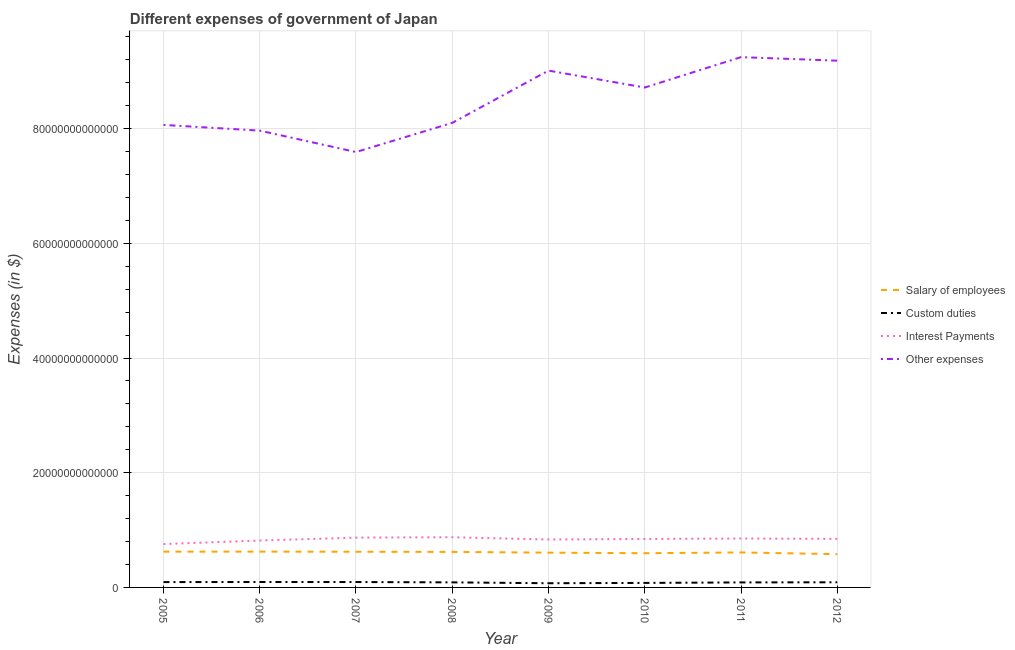Is the number of lines equal to the number of legend labels?
Your answer should be compact. Yes. What is the amount spent on salary of employees in 2009?
Your answer should be very brief. 6.06e+12. Across all years, what is the maximum amount spent on other expenses?
Offer a very short reply. 9.25e+13. Across all years, what is the minimum amount spent on custom duties?
Offer a terse response. 7.32e+11. What is the total amount spent on other expenses in the graph?
Offer a very short reply. 6.79e+14. What is the difference between the amount spent on custom duties in 2007 and that in 2008?
Your answer should be very brief. 5.79e+1. What is the difference between the amount spent on custom duties in 2012 and the amount spent on salary of employees in 2009?
Ensure brevity in your answer.  -5.17e+12. What is the average amount spent on custom duties per year?
Provide a succinct answer. 8.74e+11. In the year 2012, what is the difference between the amount spent on interest payments and amount spent on custom duties?
Ensure brevity in your answer.  7.57e+12. In how many years, is the amount spent on salary of employees greater than 32000000000000 $?
Make the answer very short. 0. What is the ratio of the amount spent on other expenses in 2008 to that in 2011?
Your response must be concise. 0.88. Is the amount spent on custom duties in 2005 less than that in 2006?
Ensure brevity in your answer.  Yes. What is the difference between the highest and the second highest amount spent on salary of employees?
Ensure brevity in your answer.  4.30e+09. What is the difference between the highest and the lowest amount spent on other expenses?
Ensure brevity in your answer.  1.65e+13. Is the sum of the amount spent on other expenses in 2008 and 2010 greater than the maximum amount spent on custom duties across all years?
Keep it short and to the point. Yes. Does the amount spent on salary of employees monotonically increase over the years?
Keep it short and to the point. No. How many lines are there?
Give a very brief answer. 4. What is the difference between two consecutive major ticks on the Y-axis?
Give a very brief answer. 2.00e+13. Are the values on the major ticks of Y-axis written in scientific E-notation?
Provide a succinct answer. No. Does the graph contain grids?
Keep it short and to the point. Yes. Where does the legend appear in the graph?
Offer a terse response. Center right. How many legend labels are there?
Give a very brief answer. 4. How are the legend labels stacked?
Ensure brevity in your answer.  Vertical. What is the title of the graph?
Ensure brevity in your answer.  Different expenses of government of Japan. What is the label or title of the X-axis?
Offer a terse response. Year. What is the label or title of the Y-axis?
Keep it short and to the point. Expenses (in $). What is the Expenses (in $) of Salary of employees in 2005?
Keep it short and to the point. 6.24e+12. What is the Expenses (in $) of Custom duties in 2005?
Your answer should be very brief. 9.30e+11. What is the Expenses (in $) in Interest Payments in 2005?
Give a very brief answer. 7.56e+12. What is the Expenses (in $) of Other expenses in 2005?
Provide a succinct answer. 8.07e+13. What is the Expenses (in $) of Salary of employees in 2006?
Make the answer very short. 6.24e+12. What is the Expenses (in $) in Custom duties in 2006?
Offer a terse response. 9.47e+11. What is the Expenses (in $) of Interest Payments in 2006?
Your answer should be compact. 8.18e+12. What is the Expenses (in $) in Other expenses in 2006?
Offer a very short reply. 7.97e+13. What is the Expenses (in $) of Salary of employees in 2007?
Your response must be concise. 6.23e+12. What is the Expenses (in $) in Custom duties in 2007?
Your answer should be compact. 9.41e+11. What is the Expenses (in $) in Interest Payments in 2007?
Make the answer very short. 8.68e+12. What is the Expenses (in $) of Other expenses in 2007?
Offer a terse response. 7.59e+13. What is the Expenses (in $) in Salary of employees in 2008?
Ensure brevity in your answer.  6.19e+12. What is the Expenses (in $) of Custom duties in 2008?
Offer a very short reply. 8.83e+11. What is the Expenses (in $) of Interest Payments in 2008?
Keep it short and to the point. 8.75e+12. What is the Expenses (in $) of Other expenses in 2008?
Provide a succinct answer. 8.10e+13. What is the Expenses (in $) of Salary of employees in 2009?
Offer a very short reply. 6.06e+12. What is the Expenses (in $) of Custom duties in 2009?
Provide a short and direct response. 7.32e+11. What is the Expenses (in $) in Interest Payments in 2009?
Provide a succinct answer. 8.35e+12. What is the Expenses (in $) in Other expenses in 2009?
Offer a terse response. 9.01e+13. What is the Expenses (in $) in Salary of employees in 2010?
Your answer should be compact. 5.97e+12. What is the Expenses (in $) in Custom duties in 2010?
Your response must be concise. 7.86e+11. What is the Expenses (in $) in Interest Payments in 2010?
Your response must be concise. 8.45e+12. What is the Expenses (in $) in Other expenses in 2010?
Offer a terse response. 8.72e+13. What is the Expenses (in $) of Salary of employees in 2011?
Make the answer very short. 6.10e+12. What is the Expenses (in $) of Custom duties in 2011?
Offer a terse response. 8.74e+11. What is the Expenses (in $) in Interest Payments in 2011?
Your answer should be very brief. 8.53e+12. What is the Expenses (in $) in Other expenses in 2011?
Keep it short and to the point. 9.25e+13. What is the Expenses (in $) of Salary of employees in 2012?
Your response must be concise. 5.80e+12. What is the Expenses (in $) of Custom duties in 2012?
Make the answer very short. 8.97e+11. What is the Expenses (in $) of Interest Payments in 2012?
Provide a succinct answer. 8.47e+12. What is the Expenses (in $) in Other expenses in 2012?
Your response must be concise. 9.19e+13. Across all years, what is the maximum Expenses (in $) in Salary of employees?
Provide a short and direct response. 6.24e+12. Across all years, what is the maximum Expenses (in $) of Custom duties?
Make the answer very short. 9.47e+11. Across all years, what is the maximum Expenses (in $) of Interest Payments?
Offer a terse response. 8.75e+12. Across all years, what is the maximum Expenses (in $) in Other expenses?
Your answer should be very brief. 9.25e+13. Across all years, what is the minimum Expenses (in $) in Salary of employees?
Your response must be concise. 5.80e+12. Across all years, what is the minimum Expenses (in $) in Custom duties?
Make the answer very short. 7.32e+11. Across all years, what is the minimum Expenses (in $) in Interest Payments?
Your answer should be compact. 7.56e+12. Across all years, what is the minimum Expenses (in $) of Other expenses?
Offer a terse response. 7.59e+13. What is the total Expenses (in $) of Salary of employees in the graph?
Your answer should be compact. 4.88e+13. What is the total Expenses (in $) in Custom duties in the graph?
Offer a very short reply. 6.99e+12. What is the total Expenses (in $) in Interest Payments in the graph?
Give a very brief answer. 6.70e+13. What is the total Expenses (in $) in Other expenses in the graph?
Ensure brevity in your answer.  6.79e+14. What is the difference between the Expenses (in $) in Salary of employees in 2005 and that in 2006?
Provide a short and direct response. -4.30e+09. What is the difference between the Expenses (in $) of Custom duties in 2005 and that in 2006?
Your answer should be very brief. -1.70e+1. What is the difference between the Expenses (in $) of Interest Payments in 2005 and that in 2006?
Your answer should be compact. -6.15e+11. What is the difference between the Expenses (in $) of Other expenses in 2005 and that in 2006?
Your answer should be compact. 9.96e+11. What is the difference between the Expenses (in $) in Salary of employees in 2005 and that in 2007?
Provide a short and direct response. 1.37e+1. What is the difference between the Expenses (in $) in Custom duties in 2005 and that in 2007?
Ensure brevity in your answer.  -1.07e+1. What is the difference between the Expenses (in $) of Interest Payments in 2005 and that in 2007?
Provide a short and direct response. -1.12e+12. What is the difference between the Expenses (in $) in Other expenses in 2005 and that in 2007?
Give a very brief answer. 4.73e+12. What is the difference between the Expenses (in $) of Salary of employees in 2005 and that in 2008?
Provide a short and direct response. 4.63e+1. What is the difference between the Expenses (in $) of Custom duties in 2005 and that in 2008?
Make the answer very short. 4.72e+1. What is the difference between the Expenses (in $) in Interest Payments in 2005 and that in 2008?
Your answer should be very brief. -1.19e+12. What is the difference between the Expenses (in $) of Other expenses in 2005 and that in 2008?
Ensure brevity in your answer.  -3.57e+11. What is the difference between the Expenses (in $) of Salary of employees in 2005 and that in 2009?
Provide a succinct answer. 1.76e+11. What is the difference between the Expenses (in $) of Custom duties in 2005 and that in 2009?
Your answer should be compact. 1.98e+11. What is the difference between the Expenses (in $) of Interest Payments in 2005 and that in 2009?
Your answer should be very brief. -7.90e+11. What is the difference between the Expenses (in $) in Other expenses in 2005 and that in 2009?
Give a very brief answer. -9.47e+12. What is the difference between the Expenses (in $) of Salary of employees in 2005 and that in 2010?
Keep it short and to the point. 2.73e+11. What is the difference between the Expenses (in $) of Custom duties in 2005 and that in 2010?
Your answer should be very brief. 1.44e+11. What is the difference between the Expenses (in $) in Interest Payments in 2005 and that in 2010?
Your answer should be compact. -8.91e+11. What is the difference between the Expenses (in $) of Other expenses in 2005 and that in 2010?
Provide a succinct answer. -6.52e+12. What is the difference between the Expenses (in $) of Salary of employees in 2005 and that in 2011?
Your answer should be very brief. 1.40e+11. What is the difference between the Expenses (in $) of Custom duties in 2005 and that in 2011?
Keep it short and to the point. 5.61e+1. What is the difference between the Expenses (in $) in Interest Payments in 2005 and that in 2011?
Ensure brevity in your answer.  -9.68e+11. What is the difference between the Expenses (in $) of Other expenses in 2005 and that in 2011?
Your answer should be compact. -1.18e+13. What is the difference between the Expenses (in $) in Salary of employees in 2005 and that in 2012?
Give a very brief answer. 4.36e+11. What is the difference between the Expenses (in $) in Custom duties in 2005 and that in 2012?
Your answer should be very brief. 3.31e+1. What is the difference between the Expenses (in $) of Interest Payments in 2005 and that in 2012?
Give a very brief answer. -9.04e+11. What is the difference between the Expenses (in $) of Other expenses in 2005 and that in 2012?
Your answer should be compact. -1.12e+13. What is the difference between the Expenses (in $) of Salary of employees in 2006 and that in 2007?
Keep it short and to the point. 1.80e+1. What is the difference between the Expenses (in $) in Custom duties in 2006 and that in 2007?
Your response must be concise. 6.30e+09. What is the difference between the Expenses (in $) of Interest Payments in 2006 and that in 2007?
Ensure brevity in your answer.  -5.07e+11. What is the difference between the Expenses (in $) in Other expenses in 2006 and that in 2007?
Offer a terse response. 3.73e+12. What is the difference between the Expenses (in $) in Salary of employees in 2006 and that in 2008?
Your response must be concise. 5.06e+1. What is the difference between the Expenses (in $) of Custom duties in 2006 and that in 2008?
Provide a short and direct response. 6.42e+1. What is the difference between the Expenses (in $) in Interest Payments in 2006 and that in 2008?
Give a very brief answer. -5.75e+11. What is the difference between the Expenses (in $) of Other expenses in 2006 and that in 2008?
Your answer should be compact. -1.35e+12. What is the difference between the Expenses (in $) in Salary of employees in 2006 and that in 2009?
Offer a terse response. 1.80e+11. What is the difference between the Expenses (in $) of Custom duties in 2006 and that in 2009?
Provide a short and direct response. 2.15e+11. What is the difference between the Expenses (in $) of Interest Payments in 2006 and that in 2009?
Provide a short and direct response. -1.75e+11. What is the difference between the Expenses (in $) of Other expenses in 2006 and that in 2009?
Your answer should be very brief. -1.05e+13. What is the difference between the Expenses (in $) of Salary of employees in 2006 and that in 2010?
Your answer should be very brief. 2.77e+11. What is the difference between the Expenses (in $) in Custom duties in 2006 and that in 2010?
Your answer should be compact. 1.61e+11. What is the difference between the Expenses (in $) in Interest Payments in 2006 and that in 2010?
Your answer should be very brief. -2.76e+11. What is the difference between the Expenses (in $) in Other expenses in 2006 and that in 2010?
Your answer should be very brief. -7.52e+12. What is the difference between the Expenses (in $) of Salary of employees in 2006 and that in 2011?
Keep it short and to the point. 1.44e+11. What is the difference between the Expenses (in $) of Custom duties in 2006 and that in 2011?
Offer a terse response. 7.31e+1. What is the difference between the Expenses (in $) of Interest Payments in 2006 and that in 2011?
Provide a short and direct response. -3.53e+11. What is the difference between the Expenses (in $) of Other expenses in 2006 and that in 2011?
Your response must be concise. -1.28e+13. What is the difference between the Expenses (in $) of Salary of employees in 2006 and that in 2012?
Your answer should be compact. 4.41e+11. What is the difference between the Expenses (in $) of Custom duties in 2006 and that in 2012?
Give a very brief answer. 5.01e+1. What is the difference between the Expenses (in $) in Interest Payments in 2006 and that in 2012?
Keep it short and to the point. -2.89e+11. What is the difference between the Expenses (in $) of Other expenses in 2006 and that in 2012?
Offer a terse response. -1.22e+13. What is the difference between the Expenses (in $) of Salary of employees in 2007 and that in 2008?
Keep it short and to the point. 3.26e+1. What is the difference between the Expenses (in $) of Custom duties in 2007 and that in 2008?
Your answer should be very brief. 5.79e+1. What is the difference between the Expenses (in $) in Interest Payments in 2007 and that in 2008?
Ensure brevity in your answer.  -6.80e+1. What is the difference between the Expenses (in $) of Other expenses in 2007 and that in 2008?
Make the answer very short. -5.09e+12. What is the difference between the Expenses (in $) in Salary of employees in 2007 and that in 2009?
Ensure brevity in your answer.  1.62e+11. What is the difference between the Expenses (in $) in Custom duties in 2007 and that in 2009?
Provide a succinct answer. 2.09e+11. What is the difference between the Expenses (in $) in Interest Payments in 2007 and that in 2009?
Offer a terse response. 3.32e+11. What is the difference between the Expenses (in $) in Other expenses in 2007 and that in 2009?
Your answer should be very brief. -1.42e+13. What is the difference between the Expenses (in $) of Salary of employees in 2007 and that in 2010?
Your response must be concise. 2.59e+11. What is the difference between the Expenses (in $) of Custom duties in 2007 and that in 2010?
Keep it short and to the point. 1.55e+11. What is the difference between the Expenses (in $) of Interest Payments in 2007 and that in 2010?
Provide a succinct answer. 2.30e+11. What is the difference between the Expenses (in $) in Other expenses in 2007 and that in 2010?
Offer a very short reply. -1.12e+13. What is the difference between the Expenses (in $) in Salary of employees in 2007 and that in 2011?
Make the answer very short. 1.26e+11. What is the difference between the Expenses (in $) of Custom duties in 2007 and that in 2011?
Your answer should be very brief. 6.68e+1. What is the difference between the Expenses (in $) of Interest Payments in 2007 and that in 2011?
Give a very brief answer. 1.53e+11. What is the difference between the Expenses (in $) in Other expenses in 2007 and that in 2011?
Your answer should be compact. -1.65e+13. What is the difference between the Expenses (in $) in Salary of employees in 2007 and that in 2012?
Offer a very short reply. 4.23e+11. What is the difference between the Expenses (in $) in Custom duties in 2007 and that in 2012?
Your response must be concise. 4.38e+1. What is the difference between the Expenses (in $) in Interest Payments in 2007 and that in 2012?
Make the answer very short. 2.18e+11. What is the difference between the Expenses (in $) in Other expenses in 2007 and that in 2012?
Your response must be concise. -1.59e+13. What is the difference between the Expenses (in $) in Salary of employees in 2008 and that in 2009?
Give a very brief answer. 1.30e+11. What is the difference between the Expenses (in $) of Custom duties in 2008 and that in 2009?
Keep it short and to the point. 1.51e+11. What is the difference between the Expenses (in $) in Interest Payments in 2008 and that in 2009?
Make the answer very short. 4.00e+11. What is the difference between the Expenses (in $) in Other expenses in 2008 and that in 2009?
Give a very brief answer. -9.11e+12. What is the difference between the Expenses (in $) of Salary of employees in 2008 and that in 2010?
Keep it short and to the point. 2.26e+11. What is the difference between the Expenses (in $) in Custom duties in 2008 and that in 2010?
Make the answer very short. 9.72e+1. What is the difference between the Expenses (in $) of Interest Payments in 2008 and that in 2010?
Make the answer very short. 2.98e+11. What is the difference between the Expenses (in $) of Other expenses in 2008 and that in 2010?
Provide a succinct answer. -6.16e+12. What is the difference between the Expenses (in $) of Salary of employees in 2008 and that in 2011?
Provide a short and direct response. 9.37e+1. What is the difference between the Expenses (in $) in Custom duties in 2008 and that in 2011?
Ensure brevity in your answer.  8.90e+09. What is the difference between the Expenses (in $) of Interest Payments in 2008 and that in 2011?
Offer a terse response. 2.21e+11. What is the difference between the Expenses (in $) in Other expenses in 2008 and that in 2011?
Provide a succinct answer. -1.15e+13. What is the difference between the Expenses (in $) of Salary of employees in 2008 and that in 2012?
Your answer should be compact. 3.90e+11. What is the difference between the Expenses (in $) of Custom duties in 2008 and that in 2012?
Give a very brief answer. -1.41e+1. What is the difference between the Expenses (in $) of Interest Payments in 2008 and that in 2012?
Make the answer very short. 2.86e+11. What is the difference between the Expenses (in $) in Other expenses in 2008 and that in 2012?
Provide a short and direct response. -1.08e+13. What is the difference between the Expenses (in $) in Salary of employees in 2009 and that in 2010?
Your response must be concise. 9.68e+1. What is the difference between the Expenses (in $) of Custom duties in 2009 and that in 2010?
Your answer should be compact. -5.40e+1. What is the difference between the Expenses (in $) in Interest Payments in 2009 and that in 2010?
Ensure brevity in your answer.  -1.02e+11. What is the difference between the Expenses (in $) of Other expenses in 2009 and that in 2010?
Offer a terse response. 2.95e+12. What is the difference between the Expenses (in $) of Salary of employees in 2009 and that in 2011?
Ensure brevity in your answer.  -3.58e+1. What is the difference between the Expenses (in $) of Custom duties in 2009 and that in 2011?
Make the answer very short. -1.42e+11. What is the difference between the Expenses (in $) of Interest Payments in 2009 and that in 2011?
Keep it short and to the point. -1.78e+11. What is the difference between the Expenses (in $) in Other expenses in 2009 and that in 2011?
Your response must be concise. -2.35e+12. What is the difference between the Expenses (in $) of Salary of employees in 2009 and that in 2012?
Keep it short and to the point. 2.61e+11. What is the difference between the Expenses (in $) of Custom duties in 2009 and that in 2012?
Provide a succinct answer. -1.65e+11. What is the difference between the Expenses (in $) in Interest Payments in 2009 and that in 2012?
Provide a short and direct response. -1.14e+11. What is the difference between the Expenses (in $) in Other expenses in 2009 and that in 2012?
Offer a very short reply. -1.73e+12. What is the difference between the Expenses (in $) in Salary of employees in 2010 and that in 2011?
Provide a short and direct response. -1.33e+11. What is the difference between the Expenses (in $) in Custom duties in 2010 and that in 2011?
Your response must be concise. -8.83e+1. What is the difference between the Expenses (in $) in Interest Payments in 2010 and that in 2011?
Make the answer very short. -7.70e+1. What is the difference between the Expenses (in $) in Other expenses in 2010 and that in 2011?
Offer a very short reply. -5.30e+12. What is the difference between the Expenses (in $) of Salary of employees in 2010 and that in 2012?
Provide a short and direct response. 1.64e+11. What is the difference between the Expenses (in $) in Custom duties in 2010 and that in 2012?
Keep it short and to the point. -1.11e+11. What is the difference between the Expenses (in $) in Interest Payments in 2010 and that in 2012?
Provide a short and direct response. -1.28e+1. What is the difference between the Expenses (in $) of Other expenses in 2010 and that in 2012?
Offer a very short reply. -4.68e+12. What is the difference between the Expenses (in $) in Salary of employees in 2011 and that in 2012?
Your response must be concise. 2.96e+11. What is the difference between the Expenses (in $) in Custom duties in 2011 and that in 2012?
Your response must be concise. -2.30e+1. What is the difference between the Expenses (in $) in Interest Payments in 2011 and that in 2012?
Ensure brevity in your answer.  6.42e+1. What is the difference between the Expenses (in $) of Other expenses in 2011 and that in 2012?
Provide a short and direct response. 6.18e+11. What is the difference between the Expenses (in $) of Salary of employees in 2005 and the Expenses (in $) of Custom duties in 2006?
Your response must be concise. 5.29e+12. What is the difference between the Expenses (in $) in Salary of employees in 2005 and the Expenses (in $) in Interest Payments in 2006?
Keep it short and to the point. -1.94e+12. What is the difference between the Expenses (in $) of Salary of employees in 2005 and the Expenses (in $) of Other expenses in 2006?
Offer a terse response. -7.34e+13. What is the difference between the Expenses (in $) in Custom duties in 2005 and the Expenses (in $) in Interest Payments in 2006?
Offer a very short reply. -7.25e+12. What is the difference between the Expenses (in $) in Custom duties in 2005 and the Expenses (in $) in Other expenses in 2006?
Provide a succinct answer. -7.87e+13. What is the difference between the Expenses (in $) in Interest Payments in 2005 and the Expenses (in $) in Other expenses in 2006?
Keep it short and to the point. -7.21e+13. What is the difference between the Expenses (in $) in Salary of employees in 2005 and the Expenses (in $) in Custom duties in 2007?
Ensure brevity in your answer.  5.30e+12. What is the difference between the Expenses (in $) in Salary of employees in 2005 and the Expenses (in $) in Interest Payments in 2007?
Ensure brevity in your answer.  -2.44e+12. What is the difference between the Expenses (in $) of Salary of employees in 2005 and the Expenses (in $) of Other expenses in 2007?
Give a very brief answer. -6.97e+13. What is the difference between the Expenses (in $) in Custom duties in 2005 and the Expenses (in $) in Interest Payments in 2007?
Give a very brief answer. -7.75e+12. What is the difference between the Expenses (in $) in Custom duties in 2005 and the Expenses (in $) in Other expenses in 2007?
Make the answer very short. -7.50e+13. What is the difference between the Expenses (in $) in Interest Payments in 2005 and the Expenses (in $) in Other expenses in 2007?
Keep it short and to the point. -6.84e+13. What is the difference between the Expenses (in $) of Salary of employees in 2005 and the Expenses (in $) of Custom duties in 2008?
Ensure brevity in your answer.  5.36e+12. What is the difference between the Expenses (in $) in Salary of employees in 2005 and the Expenses (in $) in Interest Payments in 2008?
Provide a short and direct response. -2.51e+12. What is the difference between the Expenses (in $) of Salary of employees in 2005 and the Expenses (in $) of Other expenses in 2008?
Provide a succinct answer. -7.48e+13. What is the difference between the Expenses (in $) of Custom duties in 2005 and the Expenses (in $) of Interest Payments in 2008?
Ensure brevity in your answer.  -7.82e+12. What is the difference between the Expenses (in $) in Custom duties in 2005 and the Expenses (in $) in Other expenses in 2008?
Ensure brevity in your answer.  -8.01e+13. What is the difference between the Expenses (in $) of Interest Payments in 2005 and the Expenses (in $) of Other expenses in 2008?
Make the answer very short. -7.34e+13. What is the difference between the Expenses (in $) in Salary of employees in 2005 and the Expenses (in $) in Custom duties in 2009?
Provide a succinct answer. 5.51e+12. What is the difference between the Expenses (in $) in Salary of employees in 2005 and the Expenses (in $) in Interest Payments in 2009?
Ensure brevity in your answer.  -2.11e+12. What is the difference between the Expenses (in $) of Salary of employees in 2005 and the Expenses (in $) of Other expenses in 2009?
Provide a short and direct response. -8.39e+13. What is the difference between the Expenses (in $) of Custom duties in 2005 and the Expenses (in $) of Interest Payments in 2009?
Offer a terse response. -7.42e+12. What is the difference between the Expenses (in $) of Custom duties in 2005 and the Expenses (in $) of Other expenses in 2009?
Your answer should be compact. -8.92e+13. What is the difference between the Expenses (in $) of Interest Payments in 2005 and the Expenses (in $) of Other expenses in 2009?
Your response must be concise. -8.26e+13. What is the difference between the Expenses (in $) in Salary of employees in 2005 and the Expenses (in $) in Custom duties in 2010?
Your response must be concise. 5.45e+12. What is the difference between the Expenses (in $) in Salary of employees in 2005 and the Expenses (in $) in Interest Payments in 2010?
Give a very brief answer. -2.21e+12. What is the difference between the Expenses (in $) in Salary of employees in 2005 and the Expenses (in $) in Other expenses in 2010?
Provide a succinct answer. -8.09e+13. What is the difference between the Expenses (in $) of Custom duties in 2005 and the Expenses (in $) of Interest Payments in 2010?
Your response must be concise. -7.52e+12. What is the difference between the Expenses (in $) of Custom duties in 2005 and the Expenses (in $) of Other expenses in 2010?
Ensure brevity in your answer.  -8.62e+13. What is the difference between the Expenses (in $) in Interest Payments in 2005 and the Expenses (in $) in Other expenses in 2010?
Keep it short and to the point. -7.96e+13. What is the difference between the Expenses (in $) in Salary of employees in 2005 and the Expenses (in $) in Custom duties in 2011?
Make the answer very short. 5.37e+12. What is the difference between the Expenses (in $) of Salary of employees in 2005 and the Expenses (in $) of Interest Payments in 2011?
Offer a terse response. -2.29e+12. What is the difference between the Expenses (in $) in Salary of employees in 2005 and the Expenses (in $) in Other expenses in 2011?
Provide a succinct answer. -8.62e+13. What is the difference between the Expenses (in $) in Custom duties in 2005 and the Expenses (in $) in Interest Payments in 2011?
Provide a succinct answer. -7.60e+12. What is the difference between the Expenses (in $) in Custom duties in 2005 and the Expenses (in $) in Other expenses in 2011?
Provide a short and direct response. -9.15e+13. What is the difference between the Expenses (in $) of Interest Payments in 2005 and the Expenses (in $) of Other expenses in 2011?
Your response must be concise. -8.49e+13. What is the difference between the Expenses (in $) of Salary of employees in 2005 and the Expenses (in $) of Custom duties in 2012?
Your response must be concise. 5.34e+12. What is the difference between the Expenses (in $) of Salary of employees in 2005 and the Expenses (in $) of Interest Payments in 2012?
Provide a succinct answer. -2.23e+12. What is the difference between the Expenses (in $) of Salary of employees in 2005 and the Expenses (in $) of Other expenses in 2012?
Offer a terse response. -8.56e+13. What is the difference between the Expenses (in $) of Custom duties in 2005 and the Expenses (in $) of Interest Payments in 2012?
Offer a very short reply. -7.54e+12. What is the difference between the Expenses (in $) in Custom duties in 2005 and the Expenses (in $) in Other expenses in 2012?
Your answer should be compact. -9.09e+13. What is the difference between the Expenses (in $) of Interest Payments in 2005 and the Expenses (in $) of Other expenses in 2012?
Provide a short and direct response. -8.43e+13. What is the difference between the Expenses (in $) in Salary of employees in 2006 and the Expenses (in $) in Custom duties in 2007?
Ensure brevity in your answer.  5.30e+12. What is the difference between the Expenses (in $) in Salary of employees in 2006 and the Expenses (in $) in Interest Payments in 2007?
Offer a very short reply. -2.44e+12. What is the difference between the Expenses (in $) in Salary of employees in 2006 and the Expenses (in $) in Other expenses in 2007?
Offer a terse response. -6.97e+13. What is the difference between the Expenses (in $) of Custom duties in 2006 and the Expenses (in $) of Interest Payments in 2007?
Give a very brief answer. -7.74e+12. What is the difference between the Expenses (in $) in Custom duties in 2006 and the Expenses (in $) in Other expenses in 2007?
Provide a short and direct response. -7.50e+13. What is the difference between the Expenses (in $) of Interest Payments in 2006 and the Expenses (in $) of Other expenses in 2007?
Ensure brevity in your answer.  -6.77e+13. What is the difference between the Expenses (in $) of Salary of employees in 2006 and the Expenses (in $) of Custom duties in 2008?
Give a very brief answer. 5.36e+12. What is the difference between the Expenses (in $) of Salary of employees in 2006 and the Expenses (in $) of Interest Payments in 2008?
Provide a short and direct response. -2.51e+12. What is the difference between the Expenses (in $) of Salary of employees in 2006 and the Expenses (in $) of Other expenses in 2008?
Offer a very short reply. -7.48e+13. What is the difference between the Expenses (in $) of Custom duties in 2006 and the Expenses (in $) of Interest Payments in 2008?
Ensure brevity in your answer.  -7.80e+12. What is the difference between the Expenses (in $) in Custom duties in 2006 and the Expenses (in $) in Other expenses in 2008?
Keep it short and to the point. -8.01e+13. What is the difference between the Expenses (in $) of Interest Payments in 2006 and the Expenses (in $) of Other expenses in 2008?
Your response must be concise. -7.28e+13. What is the difference between the Expenses (in $) of Salary of employees in 2006 and the Expenses (in $) of Custom duties in 2009?
Your answer should be very brief. 5.51e+12. What is the difference between the Expenses (in $) in Salary of employees in 2006 and the Expenses (in $) in Interest Payments in 2009?
Your answer should be compact. -2.11e+12. What is the difference between the Expenses (in $) in Salary of employees in 2006 and the Expenses (in $) in Other expenses in 2009?
Offer a very short reply. -8.39e+13. What is the difference between the Expenses (in $) of Custom duties in 2006 and the Expenses (in $) of Interest Payments in 2009?
Keep it short and to the point. -7.41e+12. What is the difference between the Expenses (in $) of Custom duties in 2006 and the Expenses (in $) of Other expenses in 2009?
Provide a short and direct response. -8.92e+13. What is the difference between the Expenses (in $) in Interest Payments in 2006 and the Expenses (in $) in Other expenses in 2009?
Offer a very short reply. -8.19e+13. What is the difference between the Expenses (in $) of Salary of employees in 2006 and the Expenses (in $) of Custom duties in 2010?
Offer a terse response. 5.46e+12. What is the difference between the Expenses (in $) in Salary of employees in 2006 and the Expenses (in $) in Interest Payments in 2010?
Offer a terse response. -2.21e+12. What is the difference between the Expenses (in $) of Salary of employees in 2006 and the Expenses (in $) of Other expenses in 2010?
Your answer should be very brief. -8.09e+13. What is the difference between the Expenses (in $) of Custom duties in 2006 and the Expenses (in $) of Interest Payments in 2010?
Keep it short and to the point. -7.51e+12. What is the difference between the Expenses (in $) in Custom duties in 2006 and the Expenses (in $) in Other expenses in 2010?
Keep it short and to the point. -8.62e+13. What is the difference between the Expenses (in $) in Interest Payments in 2006 and the Expenses (in $) in Other expenses in 2010?
Your answer should be compact. -7.90e+13. What is the difference between the Expenses (in $) in Salary of employees in 2006 and the Expenses (in $) in Custom duties in 2011?
Your answer should be compact. 5.37e+12. What is the difference between the Expenses (in $) of Salary of employees in 2006 and the Expenses (in $) of Interest Payments in 2011?
Keep it short and to the point. -2.29e+12. What is the difference between the Expenses (in $) in Salary of employees in 2006 and the Expenses (in $) in Other expenses in 2011?
Your answer should be compact. -8.62e+13. What is the difference between the Expenses (in $) in Custom duties in 2006 and the Expenses (in $) in Interest Payments in 2011?
Your response must be concise. -7.58e+12. What is the difference between the Expenses (in $) of Custom duties in 2006 and the Expenses (in $) of Other expenses in 2011?
Give a very brief answer. -9.15e+13. What is the difference between the Expenses (in $) of Interest Payments in 2006 and the Expenses (in $) of Other expenses in 2011?
Your response must be concise. -8.43e+13. What is the difference between the Expenses (in $) of Salary of employees in 2006 and the Expenses (in $) of Custom duties in 2012?
Offer a terse response. 5.35e+12. What is the difference between the Expenses (in $) of Salary of employees in 2006 and the Expenses (in $) of Interest Payments in 2012?
Provide a short and direct response. -2.22e+12. What is the difference between the Expenses (in $) of Salary of employees in 2006 and the Expenses (in $) of Other expenses in 2012?
Your response must be concise. -8.56e+13. What is the difference between the Expenses (in $) in Custom duties in 2006 and the Expenses (in $) in Interest Payments in 2012?
Provide a succinct answer. -7.52e+12. What is the difference between the Expenses (in $) in Custom duties in 2006 and the Expenses (in $) in Other expenses in 2012?
Keep it short and to the point. -9.09e+13. What is the difference between the Expenses (in $) of Interest Payments in 2006 and the Expenses (in $) of Other expenses in 2012?
Provide a succinct answer. -8.37e+13. What is the difference between the Expenses (in $) of Salary of employees in 2007 and the Expenses (in $) of Custom duties in 2008?
Ensure brevity in your answer.  5.34e+12. What is the difference between the Expenses (in $) of Salary of employees in 2007 and the Expenses (in $) of Interest Payments in 2008?
Your answer should be compact. -2.53e+12. What is the difference between the Expenses (in $) in Salary of employees in 2007 and the Expenses (in $) in Other expenses in 2008?
Provide a succinct answer. -7.48e+13. What is the difference between the Expenses (in $) in Custom duties in 2007 and the Expenses (in $) in Interest Payments in 2008?
Give a very brief answer. -7.81e+12. What is the difference between the Expenses (in $) of Custom duties in 2007 and the Expenses (in $) of Other expenses in 2008?
Keep it short and to the point. -8.01e+13. What is the difference between the Expenses (in $) of Interest Payments in 2007 and the Expenses (in $) of Other expenses in 2008?
Make the answer very short. -7.23e+13. What is the difference between the Expenses (in $) of Salary of employees in 2007 and the Expenses (in $) of Custom duties in 2009?
Provide a succinct answer. 5.49e+12. What is the difference between the Expenses (in $) in Salary of employees in 2007 and the Expenses (in $) in Interest Payments in 2009?
Your response must be concise. -2.13e+12. What is the difference between the Expenses (in $) in Salary of employees in 2007 and the Expenses (in $) in Other expenses in 2009?
Make the answer very short. -8.39e+13. What is the difference between the Expenses (in $) in Custom duties in 2007 and the Expenses (in $) in Interest Payments in 2009?
Ensure brevity in your answer.  -7.41e+12. What is the difference between the Expenses (in $) of Custom duties in 2007 and the Expenses (in $) of Other expenses in 2009?
Provide a short and direct response. -8.92e+13. What is the difference between the Expenses (in $) in Interest Payments in 2007 and the Expenses (in $) in Other expenses in 2009?
Make the answer very short. -8.14e+13. What is the difference between the Expenses (in $) of Salary of employees in 2007 and the Expenses (in $) of Custom duties in 2010?
Make the answer very short. 5.44e+12. What is the difference between the Expenses (in $) in Salary of employees in 2007 and the Expenses (in $) in Interest Payments in 2010?
Your answer should be compact. -2.23e+12. What is the difference between the Expenses (in $) of Salary of employees in 2007 and the Expenses (in $) of Other expenses in 2010?
Keep it short and to the point. -8.09e+13. What is the difference between the Expenses (in $) in Custom duties in 2007 and the Expenses (in $) in Interest Payments in 2010?
Provide a succinct answer. -7.51e+12. What is the difference between the Expenses (in $) in Custom duties in 2007 and the Expenses (in $) in Other expenses in 2010?
Make the answer very short. -8.62e+13. What is the difference between the Expenses (in $) of Interest Payments in 2007 and the Expenses (in $) of Other expenses in 2010?
Offer a very short reply. -7.85e+13. What is the difference between the Expenses (in $) in Salary of employees in 2007 and the Expenses (in $) in Custom duties in 2011?
Provide a short and direct response. 5.35e+12. What is the difference between the Expenses (in $) in Salary of employees in 2007 and the Expenses (in $) in Interest Payments in 2011?
Your response must be concise. -2.30e+12. What is the difference between the Expenses (in $) of Salary of employees in 2007 and the Expenses (in $) of Other expenses in 2011?
Keep it short and to the point. -8.62e+13. What is the difference between the Expenses (in $) of Custom duties in 2007 and the Expenses (in $) of Interest Payments in 2011?
Make the answer very short. -7.59e+12. What is the difference between the Expenses (in $) in Custom duties in 2007 and the Expenses (in $) in Other expenses in 2011?
Your answer should be very brief. -9.15e+13. What is the difference between the Expenses (in $) of Interest Payments in 2007 and the Expenses (in $) of Other expenses in 2011?
Your response must be concise. -8.38e+13. What is the difference between the Expenses (in $) of Salary of employees in 2007 and the Expenses (in $) of Custom duties in 2012?
Offer a very short reply. 5.33e+12. What is the difference between the Expenses (in $) of Salary of employees in 2007 and the Expenses (in $) of Interest Payments in 2012?
Your response must be concise. -2.24e+12. What is the difference between the Expenses (in $) of Salary of employees in 2007 and the Expenses (in $) of Other expenses in 2012?
Give a very brief answer. -8.56e+13. What is the difference between the Expenses (in $) of Custom duties in 2007 and the Expenses (in $) of Interest Payments in 2012?
Your answer should be very brief. -7.53e+12. What is the difference between the Expenses (in $) of Custom duties in 2007 and the Expenses (in $) of Other expenses in 2012?
Your answer should be very brief. -9.09e+13. What is the difference between the Expenses (in $) in Interest Payments in 2007 and the Expenses (in $) in Other expenses in 2012?
Offer a terse response. -8.32e+13. What is the difference between the Expenses (in $) of Salary of employees in 2008 and the Expenses (in $) of Custom duties in 2009?
Offer a very short reply. 5.46e+12. What is the difference between the Expenses (in $) of Salary of employees in 2008 and the Expenses (in $) of Interest Payments in 2009?
Offer a very short reply. -2.16e+12. What is the difference between the Expenses (in $) in Salary of employees in 2008 and the Expenses (in $) in Other expenses in 2009?
Ensure brevity in your answer.  -8.39e+13. What is the difference between the Expenses (in $) in Custom duties in 2008 and the Expenses (in $) in Interest Payments in 2009?
Provide a short and direct response. -7.47e+12. What is the difference between the Expenses (in $) of Custom duties in 2008 and the Expenses (in $) of Other expenses in 2009?
Give a very brief answer. -8.92e+13. What is the difference between the Expenses (in $) of Interest Payments in 2008 and the Expenses (in $) of Other expenses in 2009?
Give a very brief answer. -8.14e+13. What is the difference between the Expenses (in $) of Salary of employees in 2008 and the Expenses (in $) of Custom duties in 2010?
Provide a succinct answer. 5.41e+12. What is the difference between the Expenses (in $) in Salary of employees in 2008 and the Expenses (in $) in Interest Payments in 2010?
Make the answer very short. -2.26e+12. What is the difference between the Expenses (in $) in Salary of employees in 2008 and the Expenses (in $) in Other expenses in 2010?
Ensure brevity in your answer.  -8.10e+13. What is the difference between the Expenses (in $) of Custom duties in 2008 and the Expenses (in $) of Interest Payments in 2010?
Give a very brief answer. -7.57e+12. What is the difference between the Expenses (in $) in Custom duties in 2008 and the Expenses (in $) in Other expenses in 2010?
Offer a terse response. -8.63e+13. What is the difference between the Expenses (in $) in Interest Payments in 2008 and the Expenses (in $) in Other expenses in 2010?
Offer a very short reply. -7.84e+13. What is the difference between the Expenses (in $) in Salary of employees in 2008 and the Expenses (in $) in Custom duties in 2011?
Make the answer very short. 5.32e+12. What is the difference between the Expenses (in $) in Salary of employees in 2008 and the Expenses (in $) in Interest Payments in 2011?
Provide a succinct answer. -2.34e+12. What is the difference between the Expenses (in $) of Salary of employees in 2008 and the Expenses (in $) of Other expenses in 2011?
Your response must be concise. -8.63e+13. What is the difference between the Expenses (in $) of Custom duties in 2008 and the Expenses (in $) of Interest Payments in 2011?
Make the answer very short. -7.65e+12. What is the difference between the Expenses (in $) in Custom duties in 2008 and the Expenses (in $) in Other expenses in 2011?
Make the answer very short. -9.16e+13. What is the difference between the Expenses (in $) of Interest Payments in 2008 and the Expenses (in $) of Other expenses in 2011?
Provide a succinct answer. -8.37e+13. What is the difference between the Expenses (in $) of Salary of employees in 2008 and the Expenses (in $) of Custom duties in 2012?
Offer a terse response. 5.30e+12. What is the difference between the Expenses (in $) of Salary of employees in 2008 and the Expenses (in $) of Interest Payments in 2012?
Keep it short and to the point. -2.27e+12. What is the difference between the Expenses (in $) of Salary of employees in 2008 and the Expenses (in $) of Other expenses in 2012?
Offer a terse response. -8.57e+13. What is the difference between the Expenses (in $) of Custom duties in 2008 and the Expenses (in $) of Interest Payments in 2012?
Ensure brevity in your answer.  -7.58e+12. What is the difference between the Expenses (in $) of Custom duties in 2008 and the Expenses (in $) of Other expenses in 2012?
Make the answer very short. -9.10e+13. What is the difference between the Expenses (in $) in Interest Payments in 2008 and the Expenses (in $) in Other expenses in 2012?
Provide a short and direct response. -8.31e+13. What is the difference between the Expenses (in $) of Salary of employees in 2009 and the Expenses (in $) of Custom duties in 2010?
Your response must be concise. 5.28e+12. What is the difference between the Expenses (in $) in Salary of employees in 2009 and the Expenses (in $) in Interest Payments in 2010?
Your response must be concise. -2.39e+12. What is the difference between the Expenses (in $) of Salary of employees in 2009 and the Expenses (in $) of Other expenses in 2010?
Offer a terse response. -8.11e+13. What is the difference between the Expenses (in $) in Custom duties in 2009 and the Expenses (in $) in Interest Payments in 2010?
Your answer should be very brief. -7.72e+12. What is the difference between the Expenses (in $) in Custom duties in 2009 and the Expenses (in $) in Other expenses in 2010?
Your response must be concise. -8.64e+13. What is the difference between the Expenses (in $) of Interest Payments in 2009 and the Expenses (in $) of Other expenses in 2010?
Make the answer very short. -7.88e+13. What is the difference between the Expenses (in $) in Salary of employees in 2009 and the Expenses (in $) in Custom duties in 2011?
Ensure brevity in your answer.  5.19e+12. What is the difference between the Expenses (in $) of Salary of employees in 2009 and the Expenses (in $) of Interest Payments in 2011?
Ensure brevity in your answer.  -2.47e+12. What is the difference between the Expenses (in $) of Salary of employees in 2009 and the Expenses (in $) of Other expenses in 2011?
Provide a succinct answer. -8.64e+13. What is the difference between the Expenses (in $) of Custom duties in 2009 and the Expenses (in $) of Interest Payments in 2011?
Offer a very short reply. -7.80e+12. What is the difference between the Expenses (in $) of Custom duties in 2009 and the Expenses (in $) of Other expenses in 2011?
Ensure brevity in your answer.  -9.17e+13. What is the difference between the Expenses (in $) of Interest Payments in 2009 and the Expenses (in $) of Other expenses in 2011?
Offer a very short reply. -8.41e+13. What is the difference between the Expenses (in $) in Salary of employees in 2009 and the Expenses (in $) in Custom duties in 2012?
Your answer should be very brief. 5.17e+12. What is the difference between the Expenses (in $) in Salary of employees in 2009 and the Expenses (in $) in Interest Payments in 2012?
Your answer should be compact. -2.40e+12. What is the difference between the Expenses (in $) of Salary of employees in 2009 and the Expenses (in $) of Other expenses in 2012?
Your answer should be very brief. -8.58e+13. What is the difference between the Expenses (in $) of Custom duties in 2009 and the Expenses (in $) of Interest Payments in 2012?
Provide a short and direct response. -7.73e+12. What is the difference between the Expenses (in $) of Custom duties in 2009 and the Expenses (in $) of Other expenses in 2012?
Ensure brevity in your answer.  -9.11e+13. What is the difference between the Expenses (in $) in Interest Payments in 2009 and the Expenses (in $) in Other expenses in 2012?
Offer a terse response. -8.35e+13. What is the difference between the Expenses (in $) of Salary of employees in 2010 and the Expenses (in $) of Custom duties in 2011?
Ensure brevity in your answer.  5.09e+12. What is the difference between the Expenses (in $) of Salary of employees in 2010 and the Expenses (in $) of Interest Payments in 2011?
Your response must be concise. -2.56e+12. What is the difference between the Expenses (in $) of Salary of employees in 2010 and the Expenses (in $) of Other expenses in 2011?
Offer a terse response. -8.65e+13. What is the difference between the Expenses (in $) of Custom duties in 2010 and the Expenses (in $) of Interest Payments in 2011?
Provide a short and direct response. -7.74e+12. What is the difference between the Expenses (in $) of Custom duties in 2010 and the Expenses (in $) of Other expenses in 2011?
Your response must be concise. -9.17e+13. What is the difference between the Expenses (in $) of Interest Payments in 2010 and the Expenses (in $) of Other expenses in 2011?
Your answer should be very brief. -8.40e+13. What is the difference between the Expenses (in $) in Salary of employees in 2010 and the Expenses (in $) in Custom duties in 2012?
Make the answer very short. 5.07e+12. What is the difference between the Expenses (in $) in Salary of employees in 2010 and the Expenses (in $) in Interest Payments in 2012?
Ensure brevity in your answer.  -2.50e+12. What is the difference between the Expenses (in $) in Salary of employees in 2010 and the Expenses (in $) in Other expenses in 2012?
Provide a short and direct response. -8.59e+13. What is the difference between the Expenses (in $) of Custom duties in 2010 and the Expenses (in $) of Interest Payments in 2012?
Provide a succinct answer. -7.68e+12. What is the difference between the Expenses (in $) of Custom duties in 2010 and the Expenses (in $) of Other expenses in 2012?
Keep it short and to the point. -9.11e+13. What is the difference between the Expenses (in $) in Interest Payments in 2010 and the Expenses (in $) in Other expenses in 2012?
Keep it short and to the point. -8.34e+13. What is the difference between the Expenses (in $) in Salary of employees in 2011 and the Expenses (in $) in Custom duties in 2012?
Keep it short and to the point. 5.20e+12. What is the difference between the Expenses (in $) in Salary of employees in 2011 and the Expenses (in $) in Interest Payments in 2012?
Your answer should be compact. -2.37e+12. What is the difference between the Expenses (in $) of Salary of employees in 2011 and the Expenses (in $) of Other expenses in 2012?
Your answer should be very brief. -8.58e+13. What is the difference between the Expenses (in $) of Custom duties in 2011 and the Expenses (in $) of Interest Payments in 2012?
Offer a terse response. -7.59e+12. What is the difference between the Expenses (in $) in Custom duties in 2011 and the Expenses (in $) in Other expenses in 2012?
Your response must be concise. -9.10e+13. What is the difference between the Expenses (in $) of Interest Payments in 2011 and the Expenses (in $) of Other expenses in 2012?
Provide a short and direct response. -8.33e+13. What is the average Expenses (in $) in Salary of employees per year?
Your answer should be compact. 6.10e+12. What is the average Expenses (in $) of Custom duties per year?
Your answer should be very brief. 8.74e+11. What is the average Expenses (in $) in Interest Payments per year?
Keep it short and to the point. 8.37e+12. What is the average Expenses (in $) of Other expenses per year?
Your answer should be compact. 8.49e+13. In the year 2005, what is the difference between the Expenses (in $) in Salary of employees and Expenses (in $) in Custom duties?
Your answer should be very brief. 5.31e+12. In the year 2005, what is the difference between the Expenses (in $) in Salary of employees and Expenses (in $) in Interest Payments?
Offer a very short reply. -1.32e+12. In the year 2005, what is the difference between the Expenses (in $) in Salary of employees and Expenses (in $) in Other expenses?
Keep it short and to the point. -7.44e+13. In the year 2005, what is the difference between the Expenses (in $) in Custom duties and Expenses (in $) in Interest Payments?
Offer a very short reply. -6.63e+12. In the year 2005, what is the difference between the Expenses (in $) in Custom duties and Expenses (in $) in Other expenses?
Give a very brief answer. -7.97e+13. In the year 2005, what is the difference between the Expenses (in $) in Interest Payments and Expenses (in $) in Other expenses?
Your answer should be very brief. -7.31e+13. In the year 2006, what is the difference between the Expenses (in $) of Salary of employees and Expenses (in $) of Custom duties?
Give a very brief answer. 5.30e+12. In the year 2006, what is the difference between the Expenses (in $) in Salary of employees and Expenses (in $) in Interest Payments?
Your answer should be very brief. -1.93e+12. In the year 2006, what is the difference between the Expenses (in $) of Salary of employees and Expenses (in $) of Other expenses?
Offer a very short reply. -7.34e+13. In the year 2006, what is the difference between the Expenses (in $) of Custom duties and Expenses (in $) of Interest Payments?
Your answer should be compact. -7.23e+12. In the year 2006, what is the difference between the Expenses (in $) in Custom duties and Expenses (in $) in Other expenses?
Give a very brief answer. -7.87e+13. In the year 2006, what is the difference between the Expenses (in $) of Interest Payments and Expenses (in $) of Other expenses?
Give a very brief answer. -7.15e+13. In the year 2007, what is the difference between the Expenses (in $) of Salary of employees and Expenses (in $) of Custom duties?
Give a very brief answer. 5.28e+12. In the year 2007, what is the difference between the Expenses (in $) in Salary of employees and Expenses (in $) in Interest Payments?
Offer a very short reply. -2.46e+12. In the year 2007, what is the difference between the Expenses (in $) in Salary of employees and Expenses (in $) in Other expenses?
Provide a short and direct response. -6.97e+13. In the year 2007, what is the difference between the Expenses (in $) of Custom duties and Expenses (in $) of Interest Payments?
Give a very brief answer. -7.74e+12. In the year 2007, what is the difference between the Expenses (in $) of Custom duties and Expenses (in $) of Other expenses?
Make the answer very short. -7.50e+13. In the year 2007, what is the difference between the Expenses (in $) of Interest Payments and Expenses (in $) of Other expenses?
Provide a succinct answer. -6.72e+13. In the year 2008, what is the difference between the Expenses (in $) of Salary of employees and Expenses (in $) of Custom duties?
Offer a terse response. 5.31e+12. In the year 2008, what is the difference between the Expenses (in $) of Salary of employees and Expenses (in $) of Interest Payments?
Give a very brief answer. -2.56e+12. In the year 2008, what is the difference between the Expenses (in $) in Salary of employees and Expenses (in $) in Other expenses?
Your answer should be very brief. -7.48e+13. In the year 2008, what is the difference between the Expenses (in $) of Custom duties and Expenses (in $) of Interest Payments?
Your answer should be very brief. -7.87e+12. In the year 2008, what is the difference between the Expenses (in $) of Custom duties and Expenses (in $) of Other expenses?
Offer a terse response. -8.01e+13. In the year 2008, what is the difference between the Expenses (in $) in Interest Payments and Expenses (in $) in Other expenses?
Provide a short and direct response. -7.23e+13. In the year 2009, what is the difference between the Expenses (in $) in Salary of employees and Expenses (in $) in Custom duties?
Ensure brevity in your answer.  5.33e+12. In the year 2009, what is the difference between the Expenses (in $) in Salary of employees and Expenses (in $) in Interest Payments?
Your answer should be very brief. -2.29e+12. In the year 2009, what is the difference between the Expenses (in $) in Salary of employees and Expenses (in $) in Other expenses?
Offer a very short reply. -8.41e+13. In the year 2009, what is the difference between the Expenses (in $) of Custom duties and Expenses (in $) of Interest Payments?
Your answer should be compact. -7.62e+12. In the year 2009, what is the difference between the Expenses (in $) in Custom duties and Expenses (in $) in Other expenses?
Your answer should be very brief. -8.94e+13. In the year 2009, what is the difference between the Expenses (in $) in Interest Payments and Expenses (in $) in Other expenses?
Make the answer very short. -8.18e+13. In the year 2010, what is the difference between the Expenses (in $) in Salary of employees and Expenses (in $) in Custom duties?
Offer a terse response. 5.18e+12. In the year 2010, what is the difference between the Expenses (in $) of Salary of employees and Expenses (in $) of Interest Payments?
Ensure brevity in your answer.  -2.49e+12. In the year 2010, what is the difference between the Expenses (in $) in Salary of employees and Expenses (in $) in Other expenses?
Keep it short and to the point. -8.12e+13. In the year 2010, what is the difference between the Expenses (in $) of Custom duties and Expenses (in $) of Interest Payments?
Make the answer very short. -7.67e+12. In the year 2010, what is the difference between the Expenses (in $) in Custom duties and Expenses (in $) in Other expenses?
Provide a short and direct response. -8.64e+13. In the year 2010, what is the difference between the Expenses (in $) of Interest Payments and Expenses (in $) of Other expenses?
Provide a short and direct response. -7.87e+13. In the year 2011, what is the difference between the Expenses (in $) of Salary of employees and Expenses (in $) of Custom duties?
Keep it short and to the point. 5.23e+12. In the year 2011, what is the difference between the Expenses (in $) of Salary of employees and Expenses (in $) of Interest Payments?
Your answer should be very brief. -2.43e+12. In the year 2011, what is the difference between the Expenses (in $) in Salary of employees and Expenses (in $) in Other expenses?
Provide a succinct answer. -8.64e+13. In the year 2011, what is the difference between the Expenses (in $) of Custom duties and Expenses (in $) of Interest Payments?
Your answer should be very brief. -7.66e+12. In the year 2011, what is the difference between the Expenses (in $) in Custom duties and Expenses (in $) in Other expenses?
Your answer should be compact. -9.16e+13. In the year 2011, what is the difference between the Expenses (in $) in Interest Payments and Expenses (in $) in Other expenses?
Keep it short and to the point. -8.39e+13. In the year 2012, what is the difference between the Expenses (in $) of Salary of employees and Expenses (in $) of Custom duties?
Provide a short and direct response. 4.91e+12. In the year 2012, what is the difference between the Expenses (in $) of Salary of employees and Expenses (in $) of Interest Payments?
Offer a very short reply. -2.66e+12. In the year 2012, what is the difference between the Expenses (in $) in Salary of employees and Expenses (in $) in Other expenses?
Your answer should be compact. -8.61e+13. In the year 2012, what is the difference between the Expenses (in $) of Custom duties and Expenses (in $) of Interest Payments?
Offer a very short reply. -7.57e+12. In the year 2012, what is the difference between the Expenses (in $) in Custom duties and Expenses (in $) in Other expenses?
Your answer should be very brief. -9.10e+13. In the year 2012, what is the difference between the Expenses (in $) in Interest Payments and Expenses (in $) in Other expenses?
Keep it short and to the point. -8.34e+13. What is the ratio of the Expenses (in $) of Custom duties in 2005 to that in 2006?
Ensure brevity in your answer.  0.98. What is the ratio of the Expenses (in $) in Interest Payments in 2005 to that in 2006?
Make the answer very short. 0.92. What is the ratio of the Expenses (in $) of Other expenses in 2005 to that in 2006?
Your answer should be very brief. 1.01. What is the ratio of the Expenses (in $) of Custom duties in 2005 to that in 2007?
Your answer should be compact. 0.99. What is the ratio of the Expenses (in $) of Interest Payments in 2005 to that in 2007?
Make the answer very short. 0.87. What is the ratio of the Expenses (in $) in Other expenses in 2005 to that in 2007?
Your answer should be very brief. 1.06. What is the ratio of the Expenses (in $) of Salary of employees in 2005 to that in 2008?
Provide a short and direct response. 1.01. What is the ratio of the Expenses (in $) in Custom duties in 2005 to that in 2008?
Your answer should be very brief. 1.05. What is the ratio of the Expenses (in $) in Interest Payments in 2005 to that in 2008?
Give a very brief answer. 0.86. What is the ratio of the Expenses (in $) in Other expenses in 2005 to that in 2008?
Give a very brief answer. 1. What is the ratio of the Expenses (in $) of Custom duties in 2005 to that in 2009?
Give a very brief answer. 1.27. What is the ratio of the Expenses (in $) of Interest Payments in 2005 to that in 2009?
Offer a very short reply. 0.91. What is the ratio of the Expenses (in $) in Other expenses in 2005 to that in 2009?
Make the answer very short. 0.89. What is the ratio of the Expenses (in $) in Salary of employees in 2005 to that in 2010?
Offer a terse response. 1.05. What is the ratio of the Expenses (in $) of Custom duties in 2005 to that in 2010?
Give a very brief answer. 1.18. What is the ratio of the Expenses (in $) in Interest Payments in 2005 to that in 2010?
Ensure brevity in your answer.  0.89. What is the ratio of the Expenses (in $) in Other expenses in 2005 to that in 2010?
Your response must be concise. 0.93. What is the ratio of the Expenses (in $) in Custom duties in 2005 to that in 2011?
Ensure brevity in your answer.  1.06. What is the ratio of the Expenses (in $) of Interest Payments in 2005 to that in 2011?
Offer a terse response. 0.89. What is the ratio of the Expenses (in $) in Other expenses in 2005 to that in 2011?
Ensure brevity in your answer.  0.87. What is the ratio of the Expenses (in $) of Salary of employees in 2005 to that in 2012?
Your response must be concise. 1.08. What is the ratio of the Expenses (in $) of Custom duties in 2005 to that in 2012?
Provide a short and direct response. 1.04. What is the ratio of the Expenses (in $) of Interest Payments in 2005 to that in 2012?
Offer a terse response. 0.89. What is the ratio of the Expenses (in $) in Other expenses in 2005 to that in 2012?
Make the answer very short. 0.88. What is the ratio of the Expenses (in $) in Interest Payments in 2006 to that in 2007?
Provide a succinct answer. 0.94. What is the ratio of the Expenses (in $) in Other expenses in 2006 to that in 2007?
Ensure brevity in your answer.  1.05. What is the ratio of the Expenses (in $) in Salary of employees in 2006 to that in 2008?
Ensure brevity in your answer.  1.01. What is the ratio of the Expenses (in $) in Custom duties in 2006 to that in 2008?
Your response must be concise. 1.07. What is the ratio of the Expenses (in $) in Interest Payments in 2006 to that in 2008?
Provide a succinct answer. 0.93. What is the ratio of the Expenses (in $) of Other expenses in 2006 to that in 2008?
Keep it short and to the point. 0.98. What is the ratio of the Expenses (in $) of Salary of employees in 2006 to that in 2009?
Offer a terse response. 1.03. What is the ratio of the Expenses (in $) in Custom duties in 2006 to that in 2009?
Give a very brief answer. 1.29. What is the ratio of the Expenses (in $) in Interest Payments in 2006 to that in 2009?
Make the answer very short. 0.98. What is the ratio of the Expenses (in $) in Other expenses in 2006 to that in 2009?
Ensure brevity in your answer.  0.88. What is the ratio of the Expenses (in $) in Salary of employees in 2006 to that in 2010?
Give a very brief answer. 1.05. What is the ratio of the Expenses (in $) in Custom duties in 2006 to that in 2010?
Give a very brief answer. 1.21. What is the ratio of the Expenses (in $) in Interest Payments in 2006 to that in 2010?
Your response must be concise. 0.97. What is the ratio of the Expenses (in $) in Other expenses in 2006 to that in 2010?
Keep it short and to the point. 0.91. What is the ratio of the Expenses (in $) in Salary of employees in 2006 to that in 2011?
Give a very brief answer. 1.02. What is the ratio of the Expenses (in $) of Custom duties in 2006 to that in 2011?
Offer a very short reply. 1.08. What is the ratio of the Expenses (in $) in Interest Payments in 2006 to that in 2011?
Offer a very short reply. 0.96. What is the ratio of the Expenses (in $) of Other expenses in 2006 to that in 2011?
Provide a succinct answer. 0.86. What is the ratio of the Expenses (in $) in Salary of employees in 2006 to that in 2012?
Provide a short and direct response. 1.08. What is the ratio of the Expenses (in $) of Custom duties in 2006 to that in 2012?
Your answer should be compact. 1.06. What is the ratio of the Expenses (in $) in Interest Payments in 2006 to that in 2012?
Provide a short and direct response. 0.97. What is the ratio of the Expenses (in $) in Other expenses in 2006 to that in 2012?
Make the answer very short. 0.87. What is the ratio of the Expenses (in $) of Salary of employees in 2007 to that in 2008?
Your answer should be very brief. 1.01. What is the ratio of the Expenses (in $) in Custom duties in 2007 to that in 2008?
Ensure brevity in your answer.  1.07. What is the ratio of the Expenses (in $) in Interest Payments in 2007 to that in 2008?
Keep it short and to the point. 0.99. What is the ratio of the Expenses (in $) in Other expenses in 2007 to that in 2008?
Your answer should be compact. 0.94. What is the ratio of the Expenses (in $) in Salary of employees in 2007 to that in 2009?
Keep it short and to the point. 1.03. What is the ratio of the Expenses (in $) of Interest Payments in 2007 to that in 2009?
Make the answer very short. 1.04. What is the ratio of the Expenses (in $) of Other expenses in 2007 to that in 2009?
Offer a very short reply. 0.84. What is the ratio of the Expenses (in $) of Salary of employees in 2007 to that in 2010?
Provide a succinct answer. 1.04. What is the ratio of the Expenses (in $) of Custom duties in 2007 to that in 2010?
Provide a short and direct response. 1.2. What is the ratio of the Expenses (in $) of Interest Payments in 2007 to that in 2010?
Your answer should be very brief. 1.03. What is the ratio of the Expenses (in $) in Other expenses in 2007 to that in 2010?
Ensure brevity in your answer.  0.87. What is the ratio of the Expenses (in $) of Salary of employees in 2007 to that in 2011?
Provide a short and direct response. 1.02. What is the ratio of the Expenses (in $) in Custom duties in 2007 to that in 2011?
Make the answer very short. 1.08. What is the ratio of the Expenses (in $) in Other expenses in 2007 to that in 2011?
Provide a succinct answer. 0.82. What is the ratio of the Expenses (in $) in Salary of employees in 2007 to that in 2012?
Provide a short and direct response. 1.07. What is the ratio of the Expenses (in $) of Custom duties in 2007 to that in 2012?
Offer a terse response. 1.05. What is the ratio of the Expenses (in $) of Interest Payments in 2007 to that in 2012?
Make the answer very short. 1.03. What is the ratio of the Expenses (in $) of Other expenses in 2007 to that in 2012?
Offer a very short reply. 0.83. What is the ratio of the Expenses (in $) of Salary of employees in 2008 to that in 2009?
Offer a very short reply. 1.02. What is the ratio of the Expenses (in $) of Custom duties in 2008 to that in 2009?
Offer a terse response. 1.21. What is the ratio of the Expenses (in $) in Interest Payments in 2008 to that in 2009?
Keep it short and to the point. 1.05. What is the ratio of the Expenses (in $) in Other expenses in 2008 to that in 2009?
Ensure brevity in your answer.  0.9. What is the ratio of the Expenses (in $) in Salary of employees in 2008 to that in 2010?
Give a very brief answer. 1.04. What is the ratio of the Expenses (in $) of Custom duties in 2008 to that in 2010?
Give a very brief answer. 1.12. What is the ratio of the Expenses (in $) in Interest Payments in 2008 to that in 2010?
Ensure brevity in your answer.  1.04. What is the ratio of the Expenses (in $) in Other expenses in 2008 to that in 2010?
Offer a very short reply. 0.93. What is the ratio of the Expenses (in $) in Salary of employees in 2008 to that in 2011?
Ensure brevity in your answer.  1.02. What is the ratio of the Expenses (in $) in Custom duties in 2008 to that in 2011?
Give a very brief answer. 1.01. What is the ratio of the Expenses (in $) of Other expenses in 2008 to that in 2011?
Your answer should be very brief. 0.88. What is the ratio of the Expenses (in $) in Salary of employees in 2008 to that in 2012?
Make the answer very short. 1.07. What is the ratio of the Expenses (in $) of Custom duties in 2008 to that in 2012?
Ensure brevity in your answer.  0.98. What is the ratio of the Expenses (in $) of Interest Payments in 2008 to that in 2012?
Offer a very short reply. 1.03. What is the ratio of the Expenses (in $) of Other expenses in 2008 to that in 2012?
Your response must be concise. 0.88. What is the ratio of the Expenses (in $) in Salary of employees in 2009 to that in 2010?
Your answer should be compact. 1.02. What is the ratio of the Expenses (in $) of Custom duties in 2009 to that in 2010?
Ensure brevity in your answer.  0.93. What is the ratio of the Expenses (in $) of Interest Payments in 2009 to that in 2010?
Make the answer very short. 0.99. What is the ratio of the Expenses (in $) in Other expenses in 2009 to that in 2010?
Provide a short and direct response. 1.03. What is the ratio of the Expenses (in $) of Custom duties in 2009 to that in 2011?
Your response must be concise. 0.84. What is the ratio of the Expenses (in $) of Interest Payments in 2009 to that in 2011?
Offer a very short reply. 0.98. What is the ratio of the Expenses (in $) of Other expenses in 2009 to that in 2011?
Ensure brevity in your answer.  0.97. What is the ratio of the Expenses (in $) of Salary of employees in 2009 to that in 2012?
Offer a very short reply. 1.04. What is the ratio of the Expenses (in $) of Custom duties in 2009 to that in 2012?
Provide a short and direct response. 0.82. What is the ratio of the Expenses (in $) in Interest Payments in 2009 to that in 2012?
Your answer should be very brief. 0.99. What is the ratio of the Expenses (in $) in Other expenses in 2009 to that in 2012?
Provide a short and direct response. 0.98. What is the ratio of the Expenses (in $) of Salary of employees in 2010 to that in 2011?
Give a very brief answer. 0.98. What is the ratio of the Expenses (in $) of Custom duties in 2010 to that in 2011?
Ensure brevity in your answer.  0.9. What is the ratio of the Expenses (in $) of Other expenses in 2010 to that in 2011?
Your answer should be compact. 0.94. What is the ratio of the Expenses (in $) of Salary of employees in 2010 to that in 2012?
Provide a succinct answer. 1.03. What is the ratio of the Expenses (in $) in Custom duties in 2010 to that in 2012?
Your response must be concise. 0.88. What is the ratio of the Expenses (in $) of Interest Payments in 2010 to that in 2012?
Your answer should be compact. 1. What is the ratio of the Expenses (in $) of Other expenses in 2010 to that in 2012?
Give a very brief answer. 0.95. What is the ratio of the Expenses (in $) in Salary of employees in 2011 to that in 2012?
Offer a terse response. 1.05. What is the ratio of the Expenses (in $) in Custom duties in 2011 to that in 2012?
Provide a succinct answer. 0.97. What is the ratio of the Expenses (in $) in Interest Payments in 2011 to that in 2012?
Offer a terse response. 1.01. What is the difference between the highest and the second highest Expenses (in $) in Salary of employees?
Keep it short and to the point. 4.30e+09. What is the difference between the highest and the second highest Expenses (in $) in Custom duties?
Your answer should be compact. 6.30e+09. What is the difference between the highest and the second highest Expenses (in $) of Interest Payments?
Your response must be concise. 6.80e+1. What is the difference between the highest and the second highest Expenses (in $) of Other expenses?
Give a very brief answer. 6.18e+11. What is the difference between the highest and the lowest Expenses (in $) of Salary of employees?
Keep it short and to the point. 4.41e+11. What is the difference between the highest and the lowest Expenses (in $) of Custom duties?
Offer a terse response. 2.15e+11. What is the difference between the highest and the lowest Expenses (in $) in Interest Payments?
Give a very brief answer. 1.19e+12. What is the difference between the highest and the lowest Expenses (in $) in Other expenses?
Provide a succinct answer. 1.65e+13. 